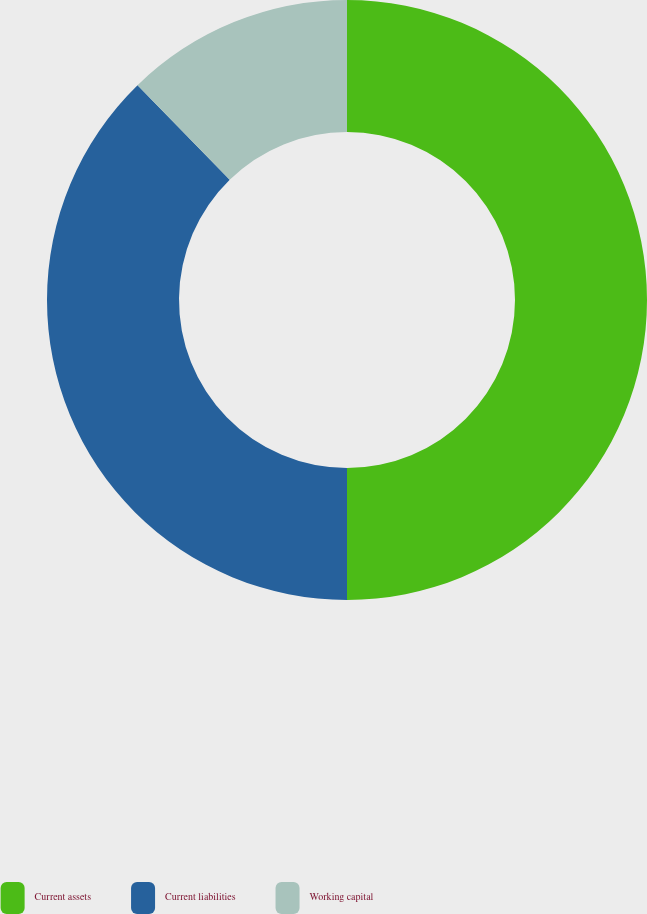Convert chart to OTSL. <chart><loc_0><loc_0><loc_500><loc_500><pie_chart><fcel>Current assets<fcel>Current liabilities<fcel>Working capital<nl><fcel>50.0%<fcel>37.7%<fcel>12.3%<nl></chart> 